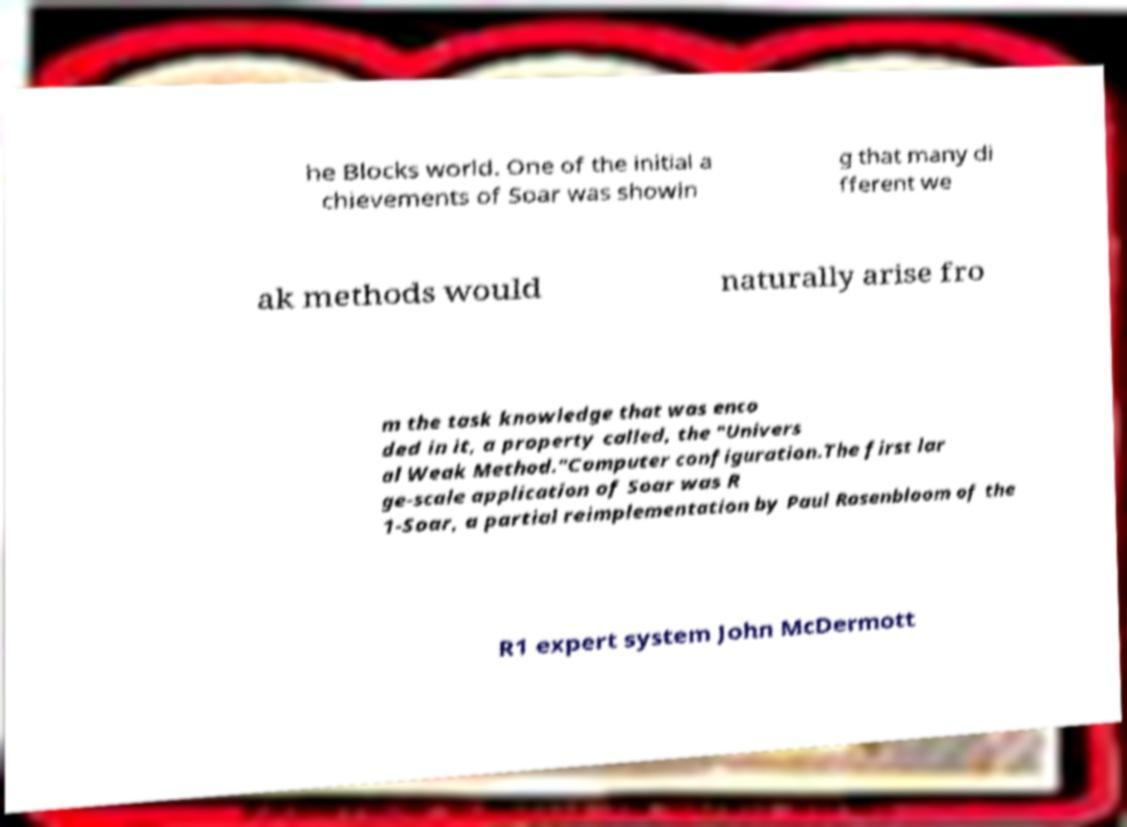For documentation purposes, I need the text within this image transcribed. Could you provide that? he Blocks world. One of the initial a chievements of Soar was showin g that many di fferent we ak methods would naturally arise fro m the task knowledge that was enco ded in it, a property called, the "Univers al Weak Method."Computer configuration.The first lar ge-scale application of Soar was R 1-Soar, a partial reimplementation by Paul Rosenbloom of the R1 expert system John McDermott 